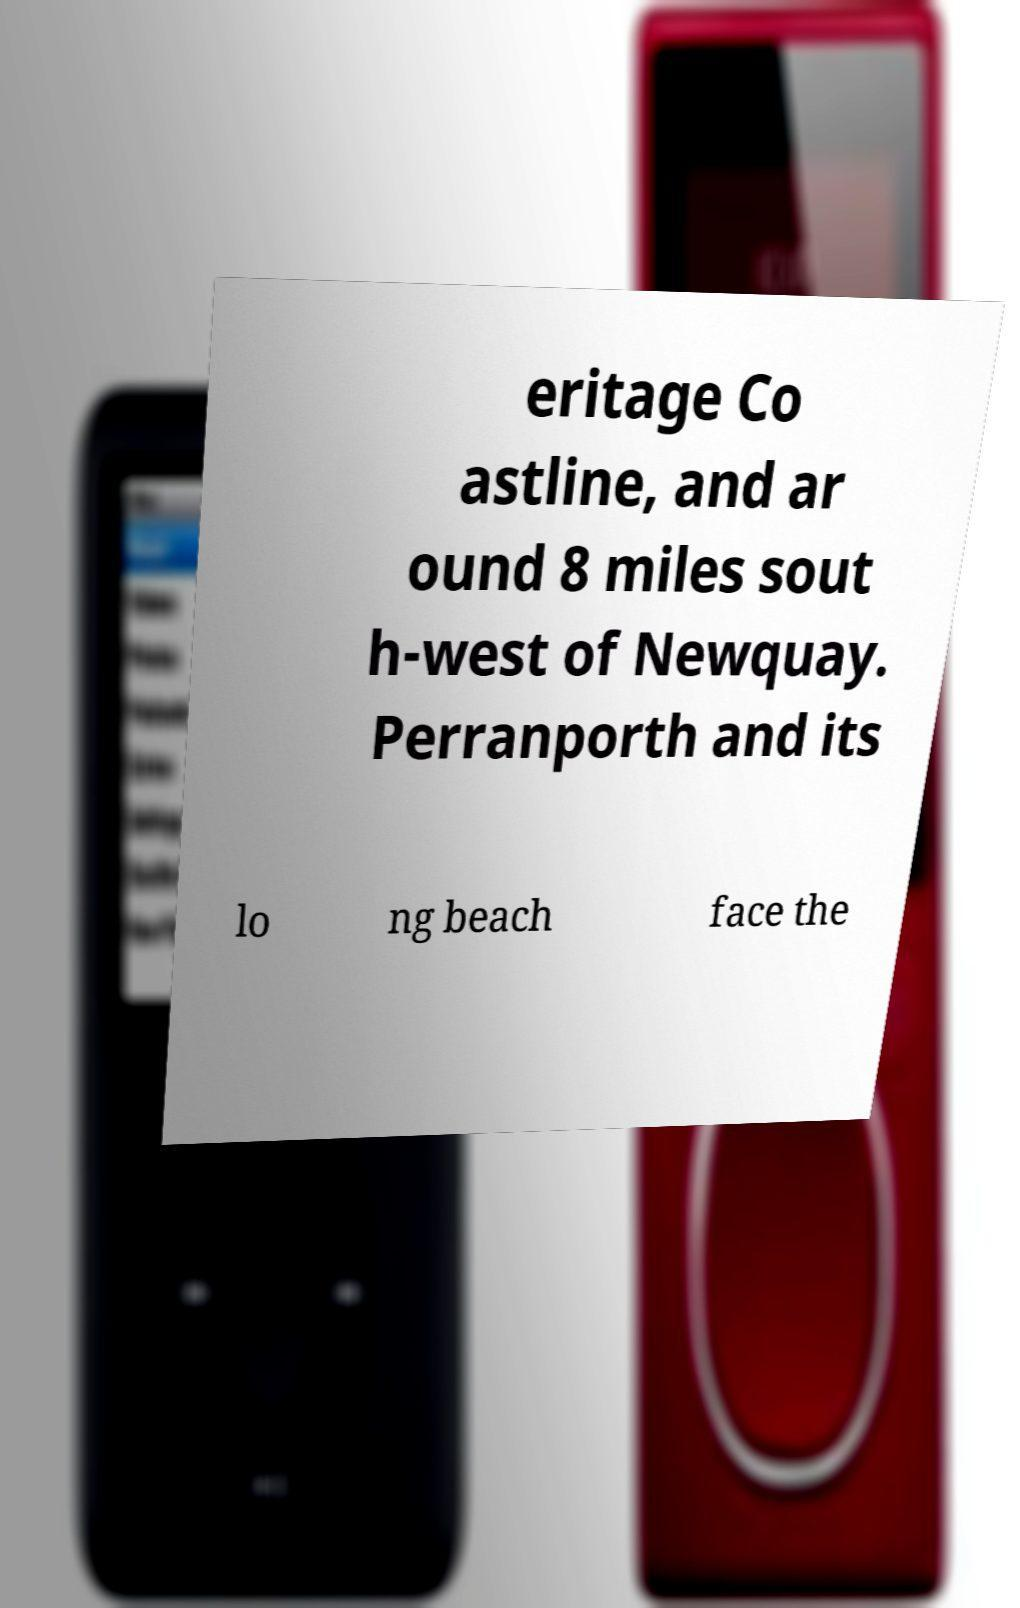Can you accurately transcribe the text from the provided image for me? eritage Co astline, and ar ound 8 miles sout h-west of Newquay. Perranporth and its lo ng beach face the 